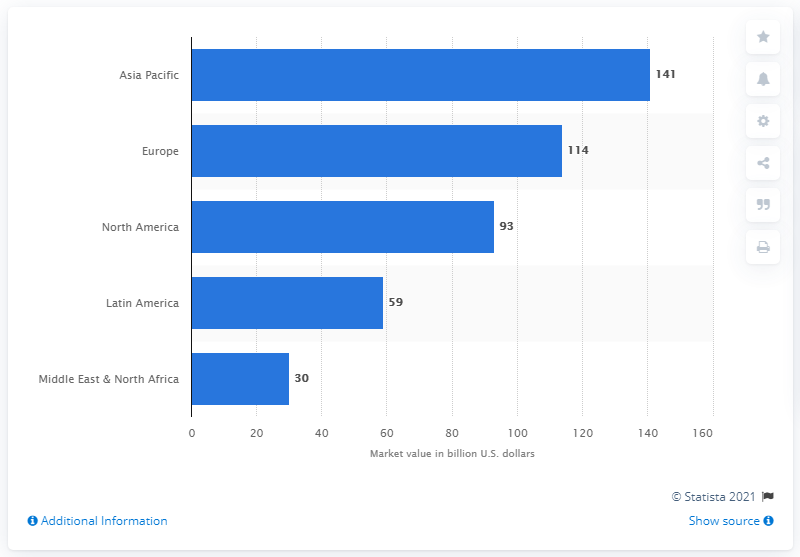List a handful of essential elements in this visual. The value of the European beauty market in 2016 was 114.. In 2016, the value of the beauty market in Asia Pacific was 141 billion dollars. 